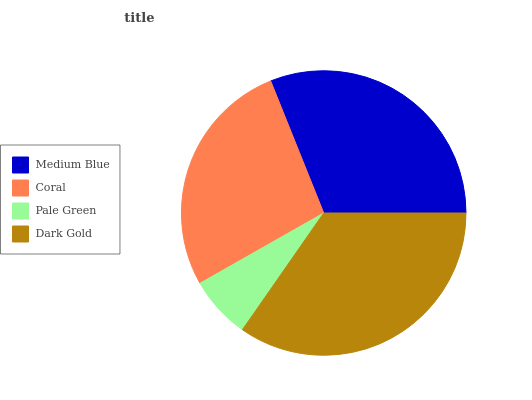Is Pale Green the minimum?
Answer yes or no. Yes. Is Dark Gold the maximum?
Answer yes or no. Yes. Is Coral the minimum?
Answer yes or no. No. Is Coral the maximum?
Answer yes or no. No. Is Medium Blue greater than Coral?
Answer yes or no. Yes. Is Coral less than Medium Blue?
Answer yes or no. Yes. Is Coral greater than Medium Blue?
Answer yes or no. No. Is Medium Blue less than Coral?
Answer yes or no. No. Is Medium Blue the high median?
Answer yes or no. Yes. Is Coral the low median?
Answer yes or no. Yes. Is Dark Gold the high median?
Answer yes or no. No. Is Medium Blue the low median?
Answer yes or no. No. 